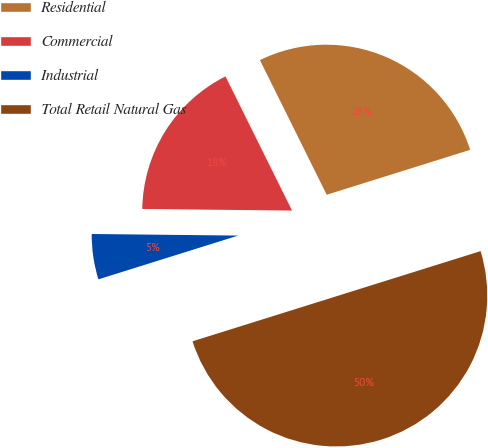<chart> <loc_0><loc_0><loc_500><loc_500><pie_chart><fcel>Residential<fcel>Commercial<fcel>Industrial<fcel>Total Retail Natural Gas<nl><fcel>27.5%<fcel>17.5%<fcel>5.0%<fcel>50.0%<nl></chart> 